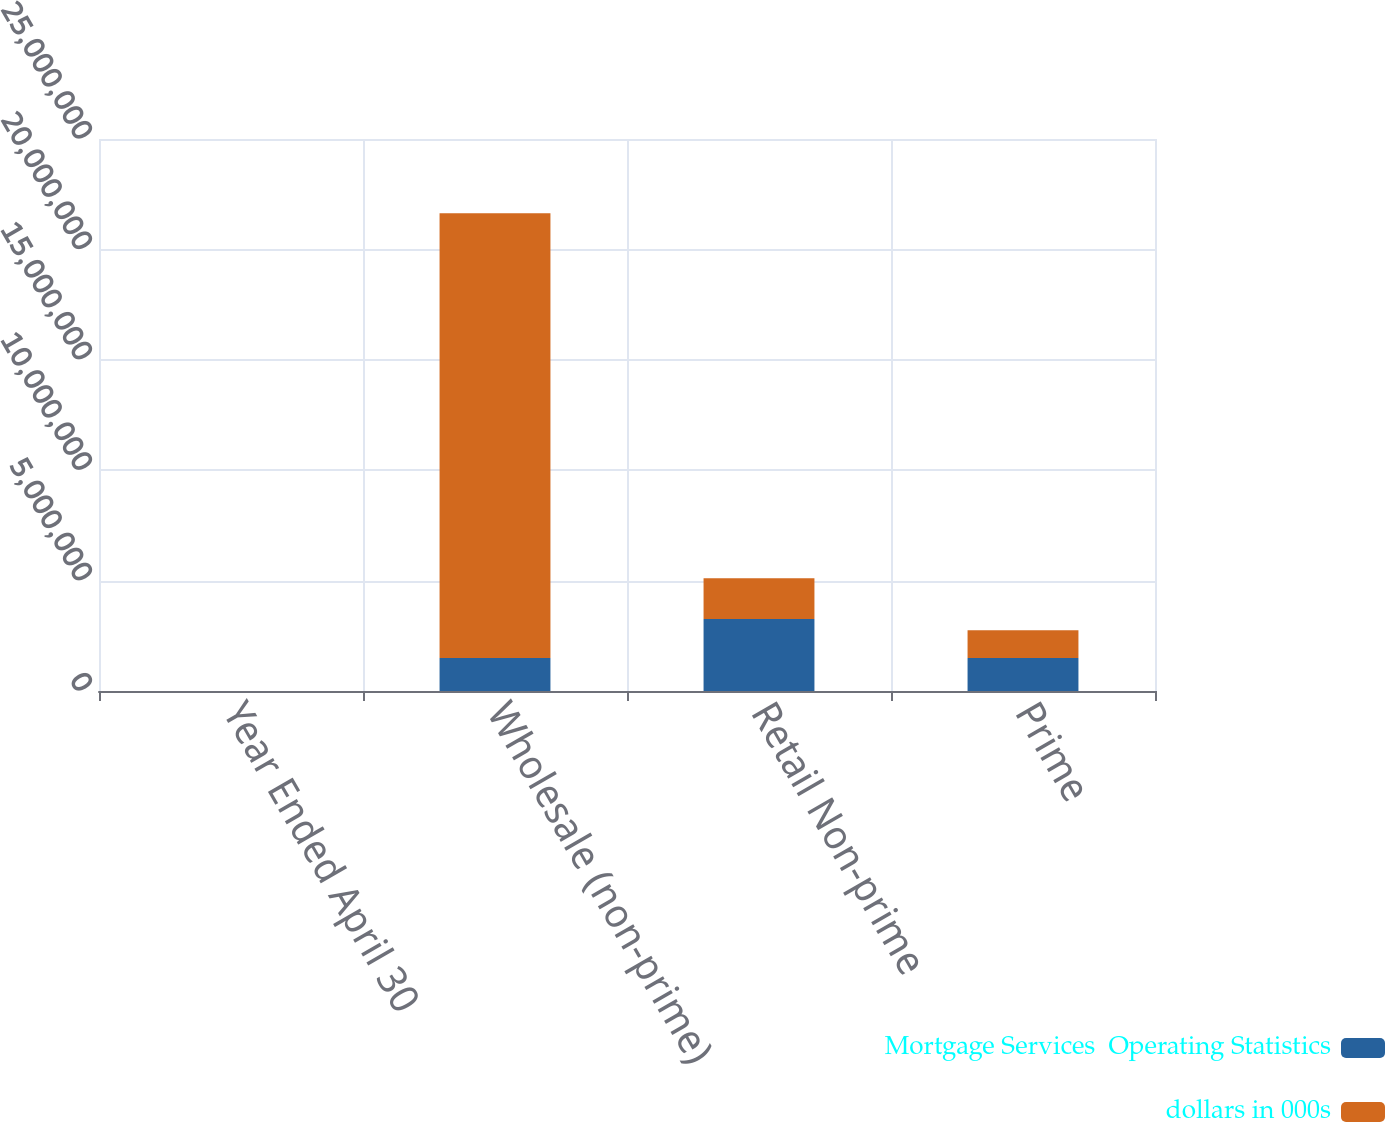Convert chart to OTSL. <chart><loc_0><loc_0><loc_500><loc_500><stacked_bar_chart><ecel><fcel>Year Ended April 30<fcel>Wholesale (non-prime)<fcel>Retail Non-prime<fcel>Prime<nl><fcel>Mortgage Services  Operating Statistics<fcel>2006<fcel>1.4909e+06<fcel>3.26007e+06<fcel>1.4909e+06<nl><fcel>dollars in 000s<fcel>2004<fcel>2.0151e+07<fcel>1.84667e+06<fcel>1.25835e+06<nl></chart> 